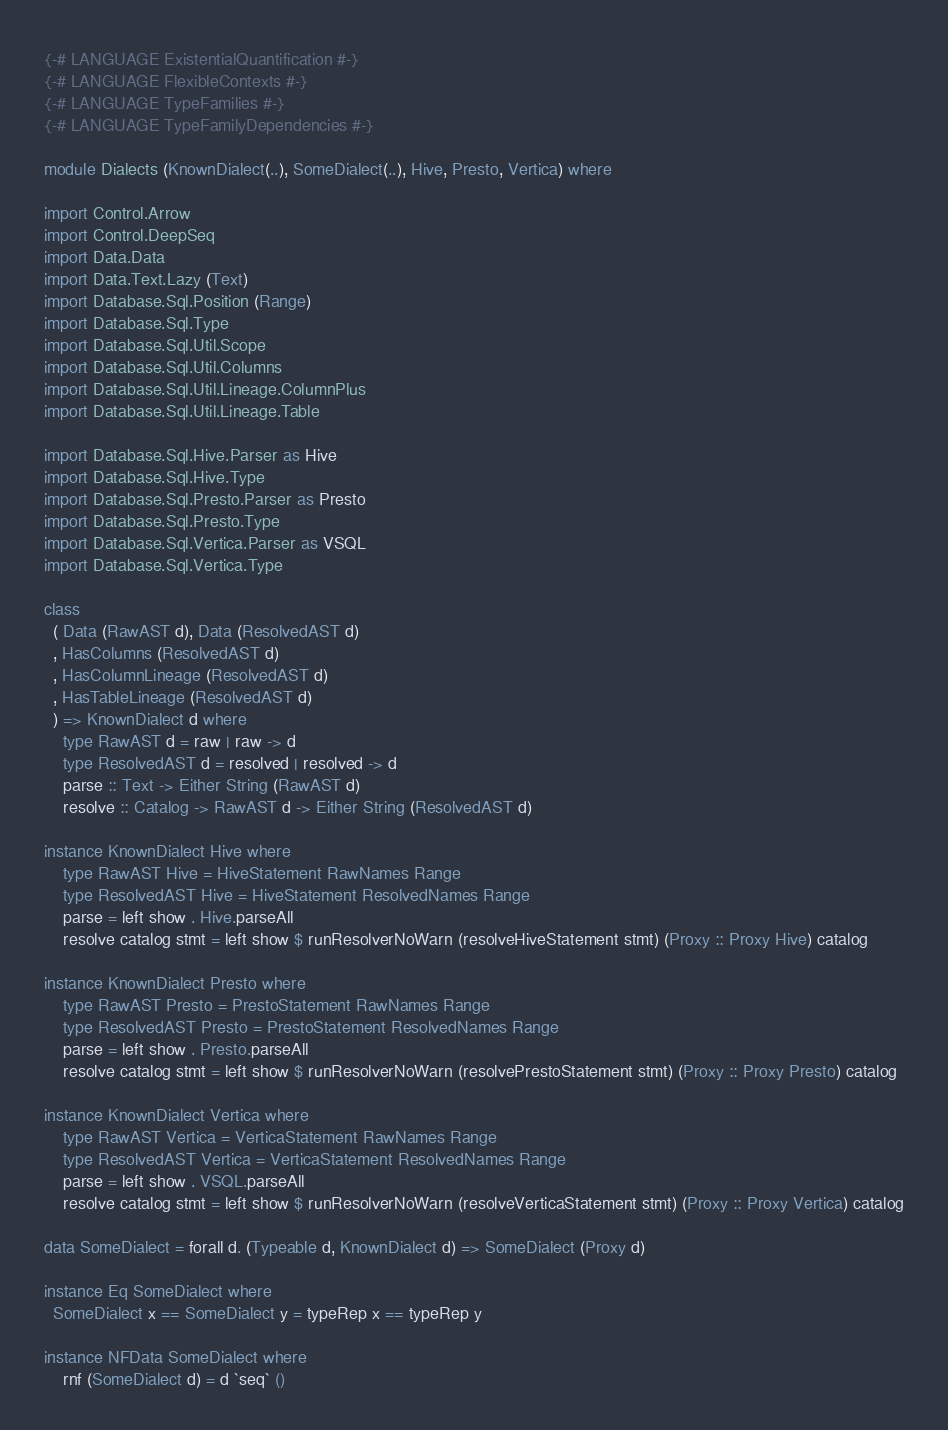<code> <loc_0><loc_0><loc_500><loc_500><_Haskell_>{-# LANGUAGE ExistentialQuantification #-}
{-# LANGUAGE FlexibleContexts #-}
{-# LANGUAGE TypeFamilies #-}
{-# LANGUAGE TypeFamilyDependencies #-}

module Dialects (KnownDialect(..), SomeDialect(..), Hive, Presto, Vertica) where

import Control.Arrow
import Control.DeepSeq
import Data.Data
import Data.Text.Lazy (Text)
import Database.Sql.Position (Range)
import Database.Sql.Type
import Database.Sql.Util.Scope
import Database.Sql.Util.Columns
import Database.Sql.Util.Lineage.ColumnPlus
import Database.Sql.Util.Lineage.Table

import Database.Sql.Hive.Parser as Hive
import Database.Sql.Hive.Type
import Database.Sql.Presto.Parser as Presto
import Database.Sql.Presto.Type
import Database.Sql.Vertica.Parser as VSQL
import Database.Sql.Vertica.Type

class
  ( Data (RawAST d), Data (ResolvedAST d)
  , HasColumns (ResolvedAST d)
  , HasColumnLineage (ResolvedAST d)
  , HasTableLineage (ResolvedAST d)
  ) => KnownDialect d where
    type RawAST d = raw | raw -> d
    type ResolvedAST d = resolved | resolved -> d
    parse :: Text -> Either String (RawAST d)
    resolve :: Catalog -> RawAST d -> Either String (ResolvedAST d)

instance KnownDialect Hive where
    type RawAST Hive = HiveStatement RawNames Range
    type ResolvedAST Hive = HiveStatement ResolvedNames Range
    parse = left show . Hive.parseAll
    resolve catalog stmt = left show $ runResolverNoWarn (resolveHiveStatement stmt) (Proxy :: Proxy Hive) catalog

instance KnownDialect Presto where
    type RawAST Presto = PrestoStatement RawNames Range
    type ResolvedAST Presto = PrestoStatement ResolvedNames Range
    parse = left show . Presto.parseAll
    resolve catalog stmt = left show $ runResolverNoWarn (resolvePrestoStatement stmt) (Proxy :: Proxy Presto) catalog

instance KnownDialect Vertica where
    type RawAST Vertica = VerticaStatement RawNames Range
    type ResolvedAST Vertica = VerticaStatement ResolvedNames Range
    parse = left show . VSQL.parseAll
    resolve catalog stmt = left show $ runResolverNoWarn (resolveVerticaStatement stmt) (Proxy :: Proxy Vertica) catalog

data SomeDialect = forall d. (Typeable d, KnownDialect d) => SomeDialect (Proxy d)

instance Eq SomeDialect where
  SomeDialect x == SomeDialect y = typeRep x == typeRep y

instance NFData SomeDialect where
    rnf (SomeDialect d) = d `seq` ()
</code> 